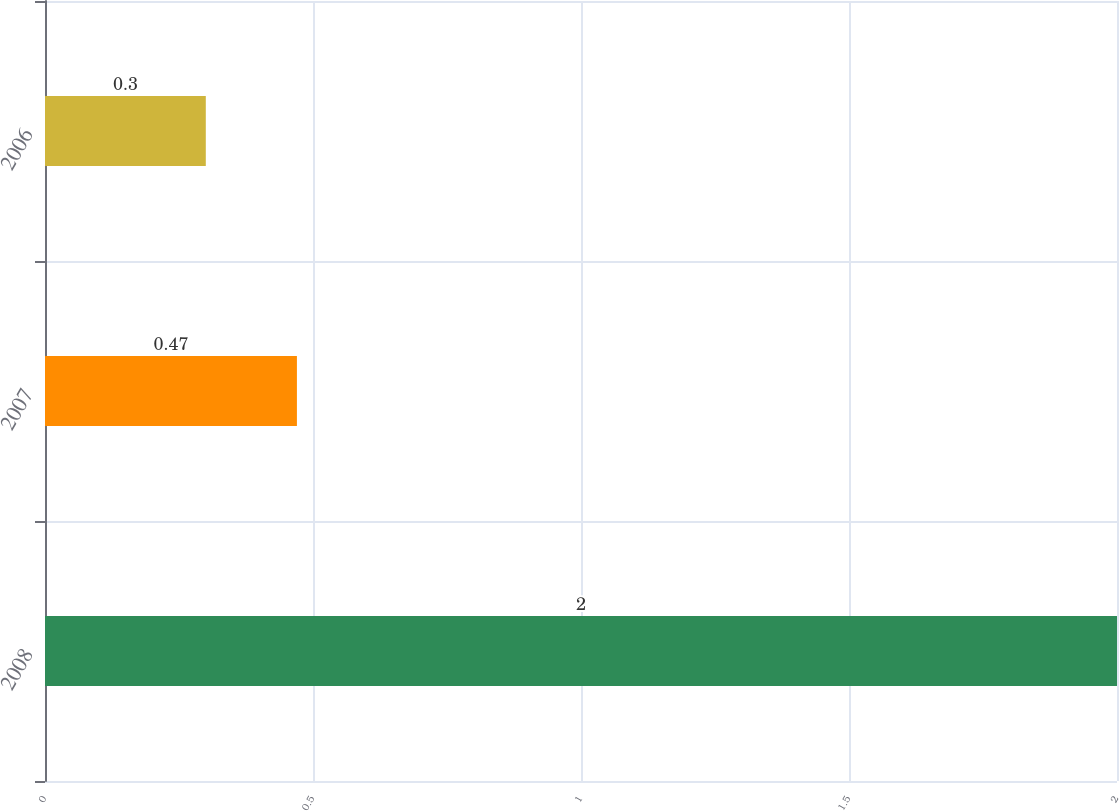Convert chart. <chart><loc_0><loc_0><loc_500><loc_500><bar_chart><fcel>2008<fcel>2007<fcel>2006<nl><fcel>2<fcel>0.47<fcel>0.3<nl></chart> 